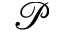<formula> <loc_0><loc_0><loc_500><loc_500>\mathcal { P }</formula> 